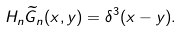Convert formula to latex. <formula><loc_0><loc_0><loc_500><loc_500>H _ { n } \widetilde { G } _ { n } ( x , y ) = \delta ^ { 3 } ( x - y ) .</formula> 